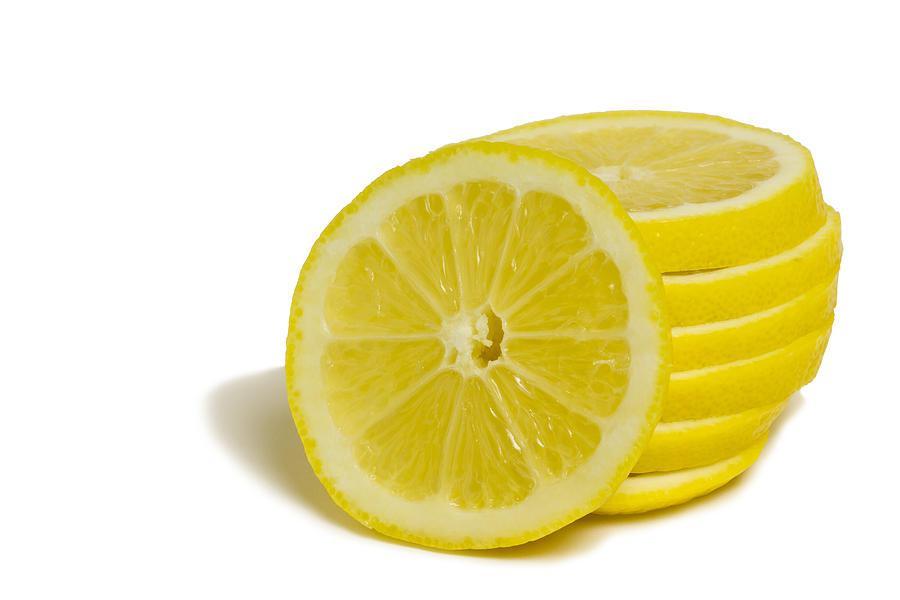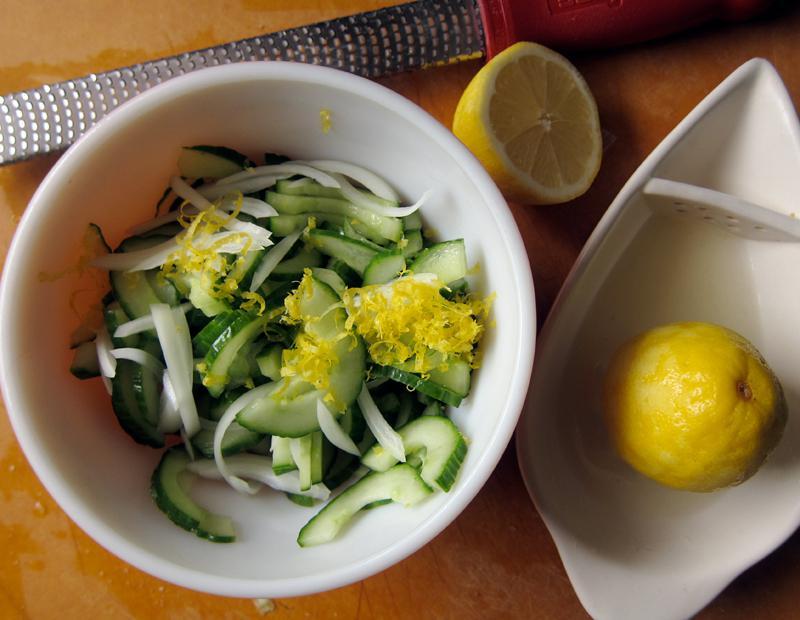The first image is the image on the left, the second image is the image on the right. Analyze the images presented: Is the assertion "One image includes whole and half lemons." valid? Answer yes or no. No. The first image is the image on the left, the second image is the image on the right. Given the left and right images, does the statement "Lemon slices appear in one image, while a second image includes one or more whole lemons." hold true? Answer yes or no. Yes. 